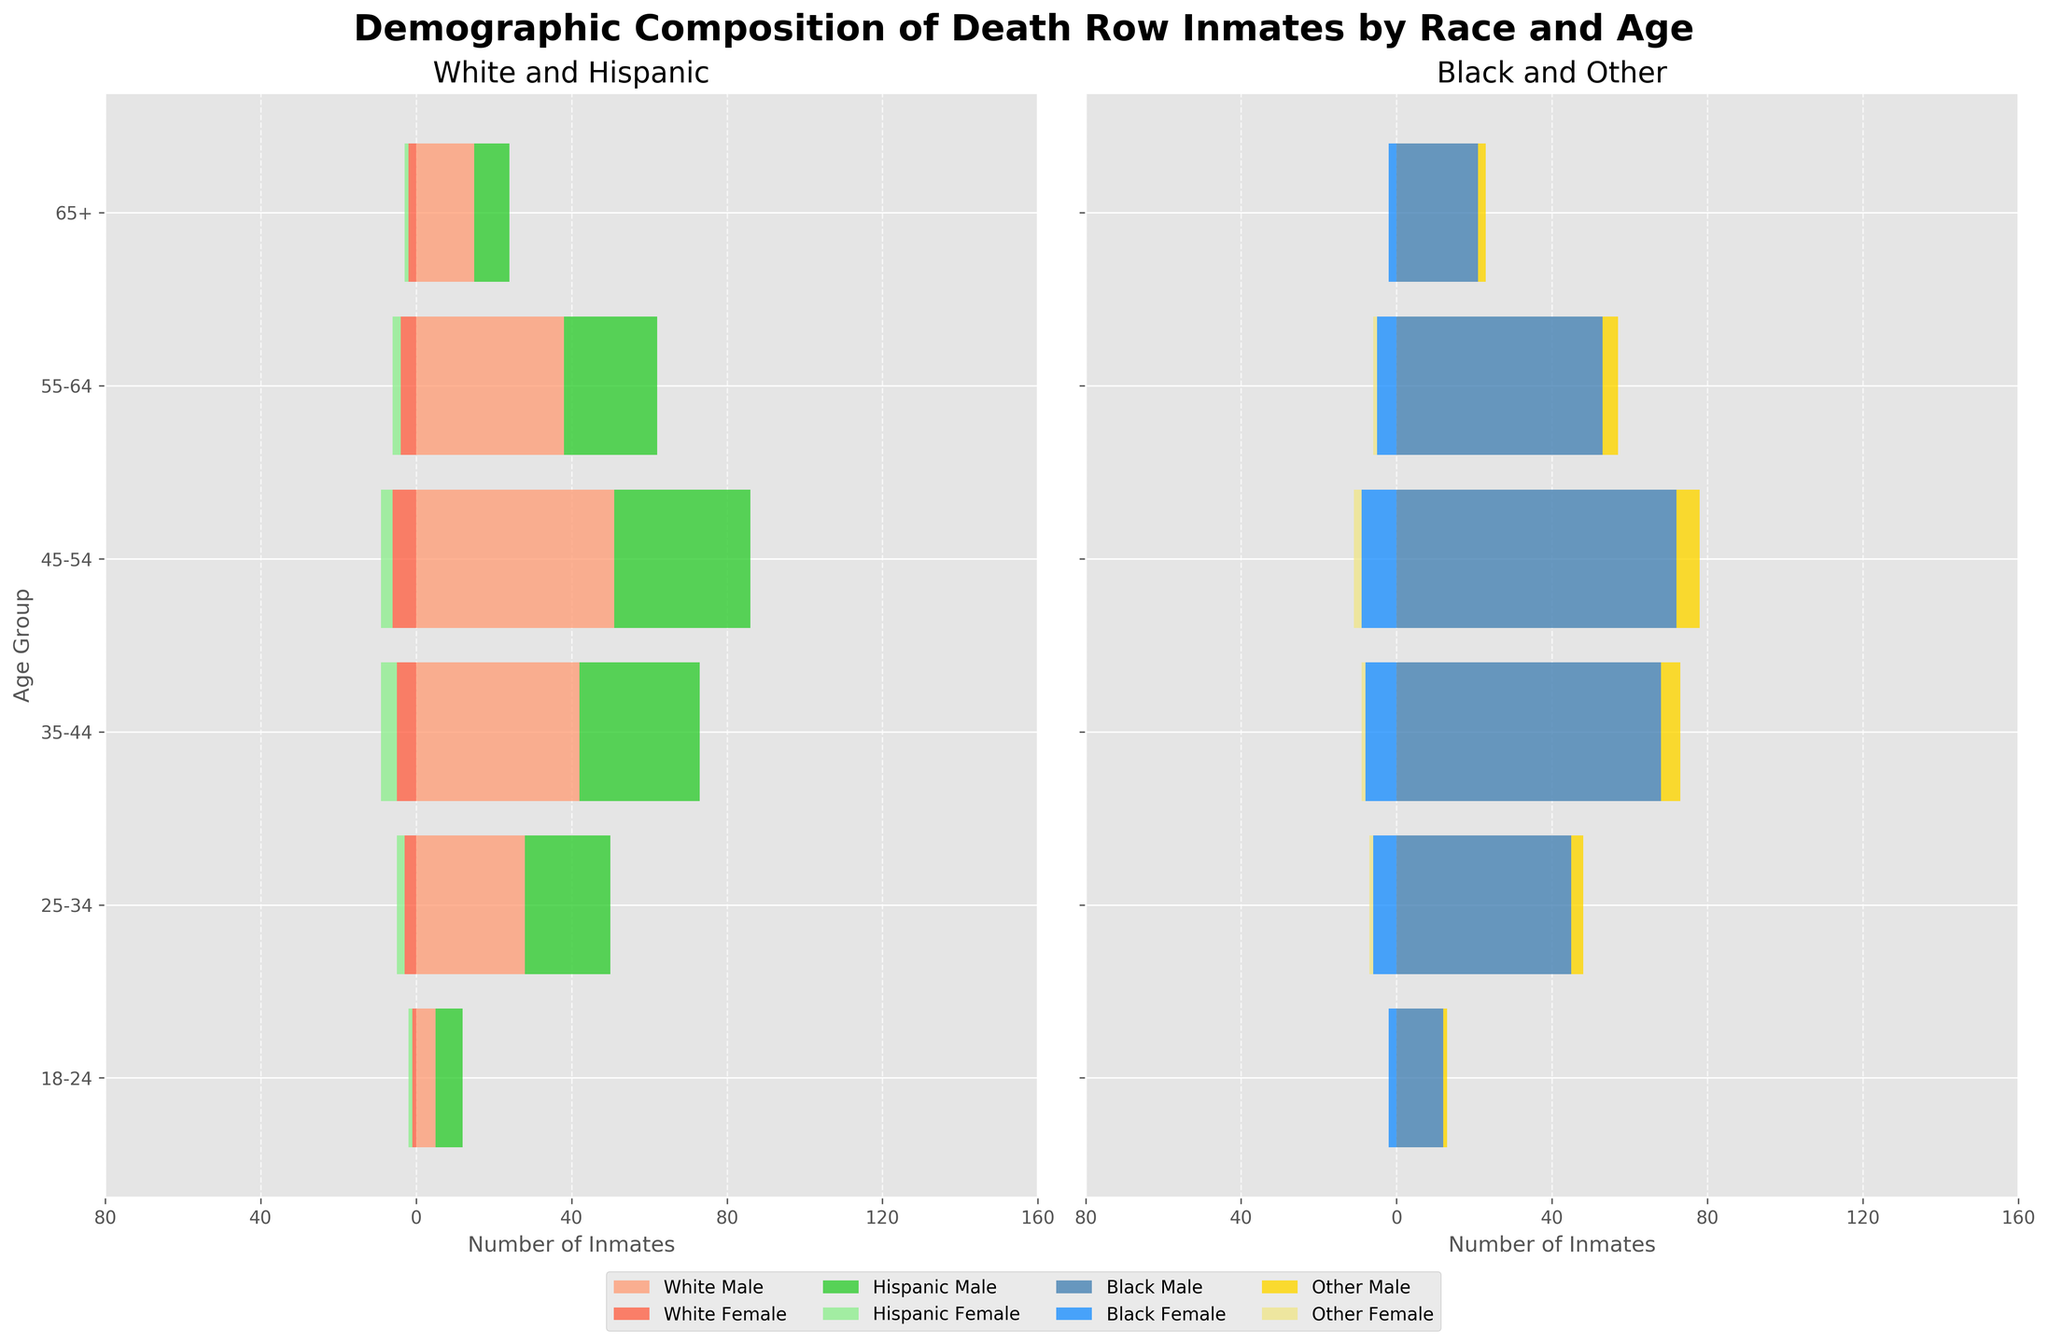What does the figure show? The figure’s title states "Demographic Composition of Death Row Inmates by Race and Age." It displays horizontal bar charts to represent the number of death row inmates across different age groups, separated by race, and gender.
Answer: Demographic composition by race and age How many Hispanic male inmates are there in the 45-54 age group? The figure has a bar for Hispanic Males in the 45-54 age group showing 35 inmates.
Answer: 35 Which age group has the highest number of Black Male death row inmates? We compare the lengths of the bars for Black Male across all age groups. The 45-54 age group bar is the longest, indicating the highest number.
Answer: 45-54 Are there more White Female or Hispanic Female inmates in the 35-44 age group? We compare the negative bars for White Female and Hispanic Female in the 35-44 age group. The White Female bar is longer, thus more numerous.
Answer: White Female What's the total count of inmates in the 18-24 age group? Summing up all the values in the 18-24 age group: 5 (White Male) + 1 (White Female) + 12 (Black Male) + 2 (Black Female) + 7 (Hispanic Male) + 1 (Hispanic Female) + 1 (Other Male) + 0 (Other Female) = 29 inmates.
Answer: 29 Which racial and gender group has the smallest representation in death row inmates? The smallest representation is the group with the smallest bar across all categories. In this chart, it is "Other Female" in most age groups, particularly 18-24 and 65+.
Answer: Other Female What’s the difference in the number of Black Male and Black Female inmates in the 55-64 age group? The number of Black Male inmates in 55-64 is 53, and Black Female inmates are 5. The difference is 53 - 5 = 48.
Answer: 48 In which age group is the total number of death row inmates highest? Summing all the figures within each age group, the 45-54 age group has the highest total: 51 (White Male) + 6 (White Female) + 72 (Black Male) + 9 (Black Female) + 35 (Hispanic Male) + 3 (Hispanic Female) + 6 (Other Male) + 2 (Other Female) = 184.
Answer: 45-54 Do Hispanic Male inmates outnumber White Male inmates in any age group? Compare the values for Hispanic Male and White Male inmates within each age group. In all age groups, White Male inmates exceed Hispanic Male inmates.
Answer: No How does the number of White Female inmates change from the 35-44 to 45-54 age groups? The bar for White Female in the 35-44 age group shows 5 inmates, while in the 45-54 age group, it shows 6. This indicates an increase of 1.
Answer: Increases by 1 